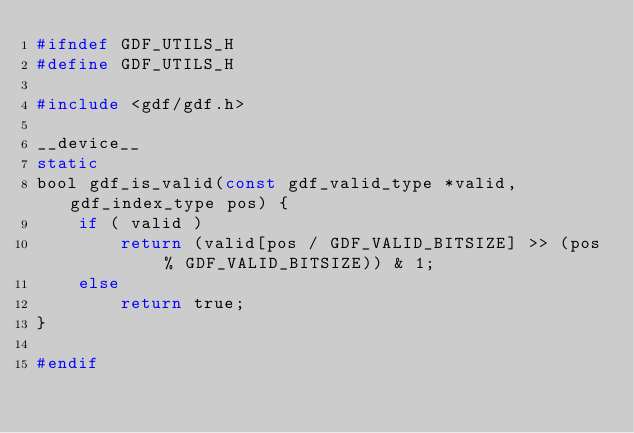<code> <loc_0><loc_0><loc_500><loc_500><_C_>#ifndef GDF_UTILS_H
#define GDF_UTILS_H

#include <gdf/gdf.h>

__device__
static
bool gdf_is_valid(const gdf_valid_type *valid, gdf_index_type pos) {
    if ( valid )
        return (valid[pos / GDF_VALID_BITSIZE] >> (pos % GDF_VALID_BITSIZE)) & 1;
    else
        return true;
}

#endif
</code> 